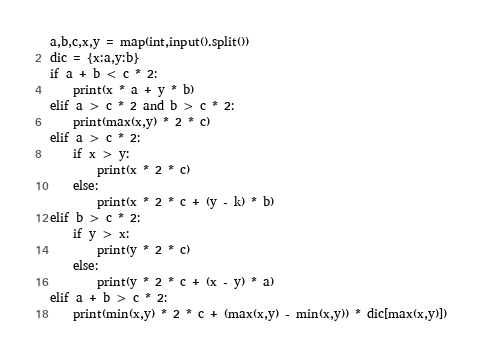Convert code to text. <code><loc_0><loc_0><loc_500><loc_500><_Python_>a,b,c,x,y = map(int,input().split())
dic = {x:a,y:b}
if a + b < c * 2:
    print(x * a + y * b)
elif a > c * 2 and b > c * 2:
    print(max(x,y) * 2 * c)
elif a > c * 2:
    if x > y:
        print(x * 2 * c)
    else:
        print(x * 2 * c + (y - k) * b)
elif b > c * 2:
    if y > x:
        print(y * 2 * c)
    else:
        print(y * 2 * c + (x - y) * a)
elif a + b > c * 2:
    print(min(x,y) * 2 * c + (max(x,y) - min(x,y)) * dic[max(x,y)])</code> 